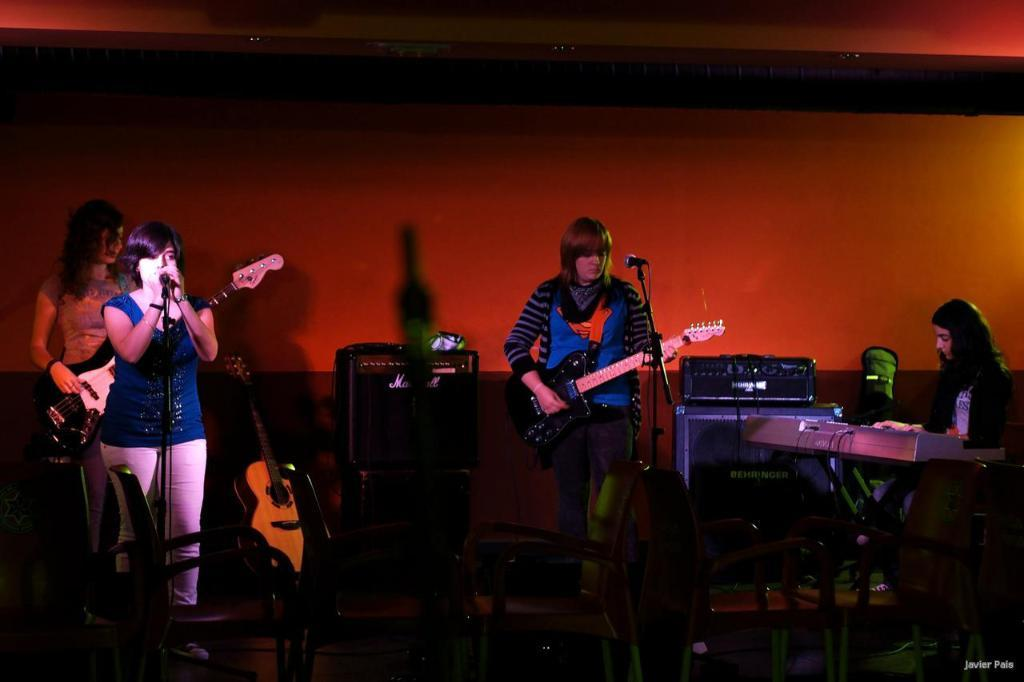What is the woman in the image doing? The woman is singing in the image. What is the woman holding while singing? The woman is in front of a microphone. Are there any other musicians in the image? Yes, there are two women playing guitars in the image. What type of chain is hanging from the wall in the image? There is no chain or wall present in the image; it features a woman singing and two women playing guitars. Can you describe the bat that is flying around the musicians in the image? There is no bat present in the image; it only features the musicians and their instruments. 